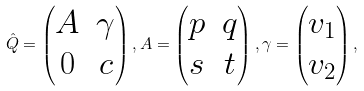<formula> <loc_0><loc_0><loc_500><loc_500>\hat { Q } = \begin{pmatrix} A & \gamma \\ 0 & c \end{pmatrix} , A = \begin{pmatrix} p & q \\ s & t \end{pmatrix} , \gamma = \begin{pmatrix} v _ { 1 } \\ v _ { 2 } \end{pmatrix} ,</formula> 